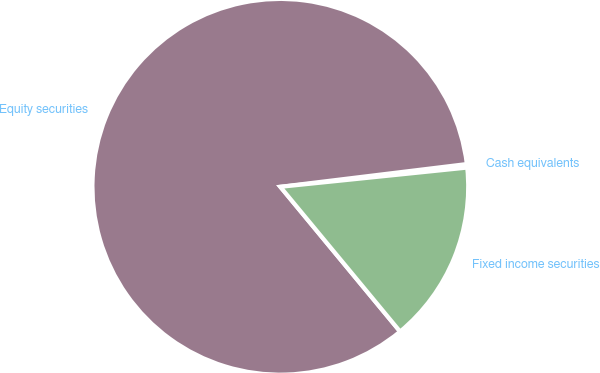<chart> <loc_0><loc_0><loc_500><loc_500><pie_chart><fcel>Cash equivalents<fcel>Equity securities<fcel>Fixed income securities<nl><fcel>0.3%<fcel>84.07%<fcel>15.63%<nl></chart> 